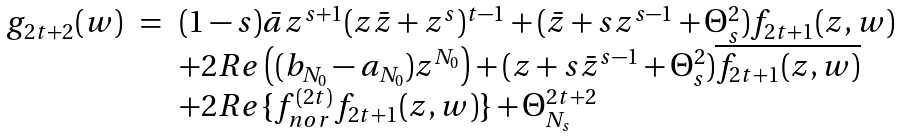Convert formula to latex. <formula><loc_0><loc_0><loc_500><loc_500>\begin{array} { r l l } g _ { 2 t + 2 } ( w ) & = & ( 1 - s ) \bar { a } z ^ { s + 1 } ( z \bar { z } + z ^ { s } ) ^ { t - 1 } + ( \bar { z } + s z ^ { s - 1 } + \Theta _ { s } ^ { 2 } ) f _ { 2 t + 1 } ( z , w ) \\ & & + 2 R e \left ( ( b _ { N _ { 0 } } - a _ { N _ { 0 } } ) z ^ { N _ { 0 } } \right ) + ( z + s \bar { z } ^ { s - 1 } + \Theta _ { s } ^ { 2 } ) \overline { f _ { 2 t + 1 } ( z , w ) } \\ & & + 2 R e \{ { f _ { n o r } ^ { ( 2 t ) } } f _ { 2 t + 1 } ( z , w ) \} + \Theta _ { N _ { s } } ^ { 2 t + 2 } \end{array}</formula> 